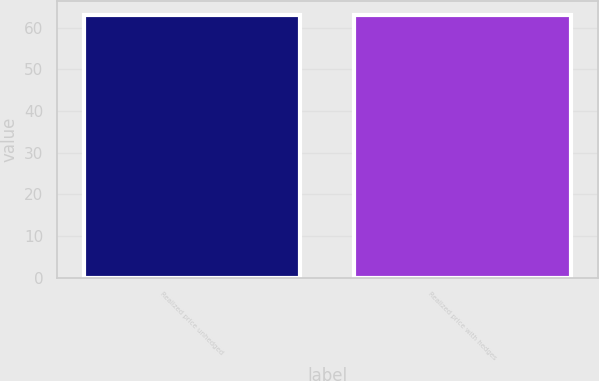<chart> <loc_0><loc_0><loc_500><loc_500><bar_chart><fcel>Realized price unhedged<fcel>Realized price with hedges<nl><fcel>63<fcel>63.1<nl></chart> 